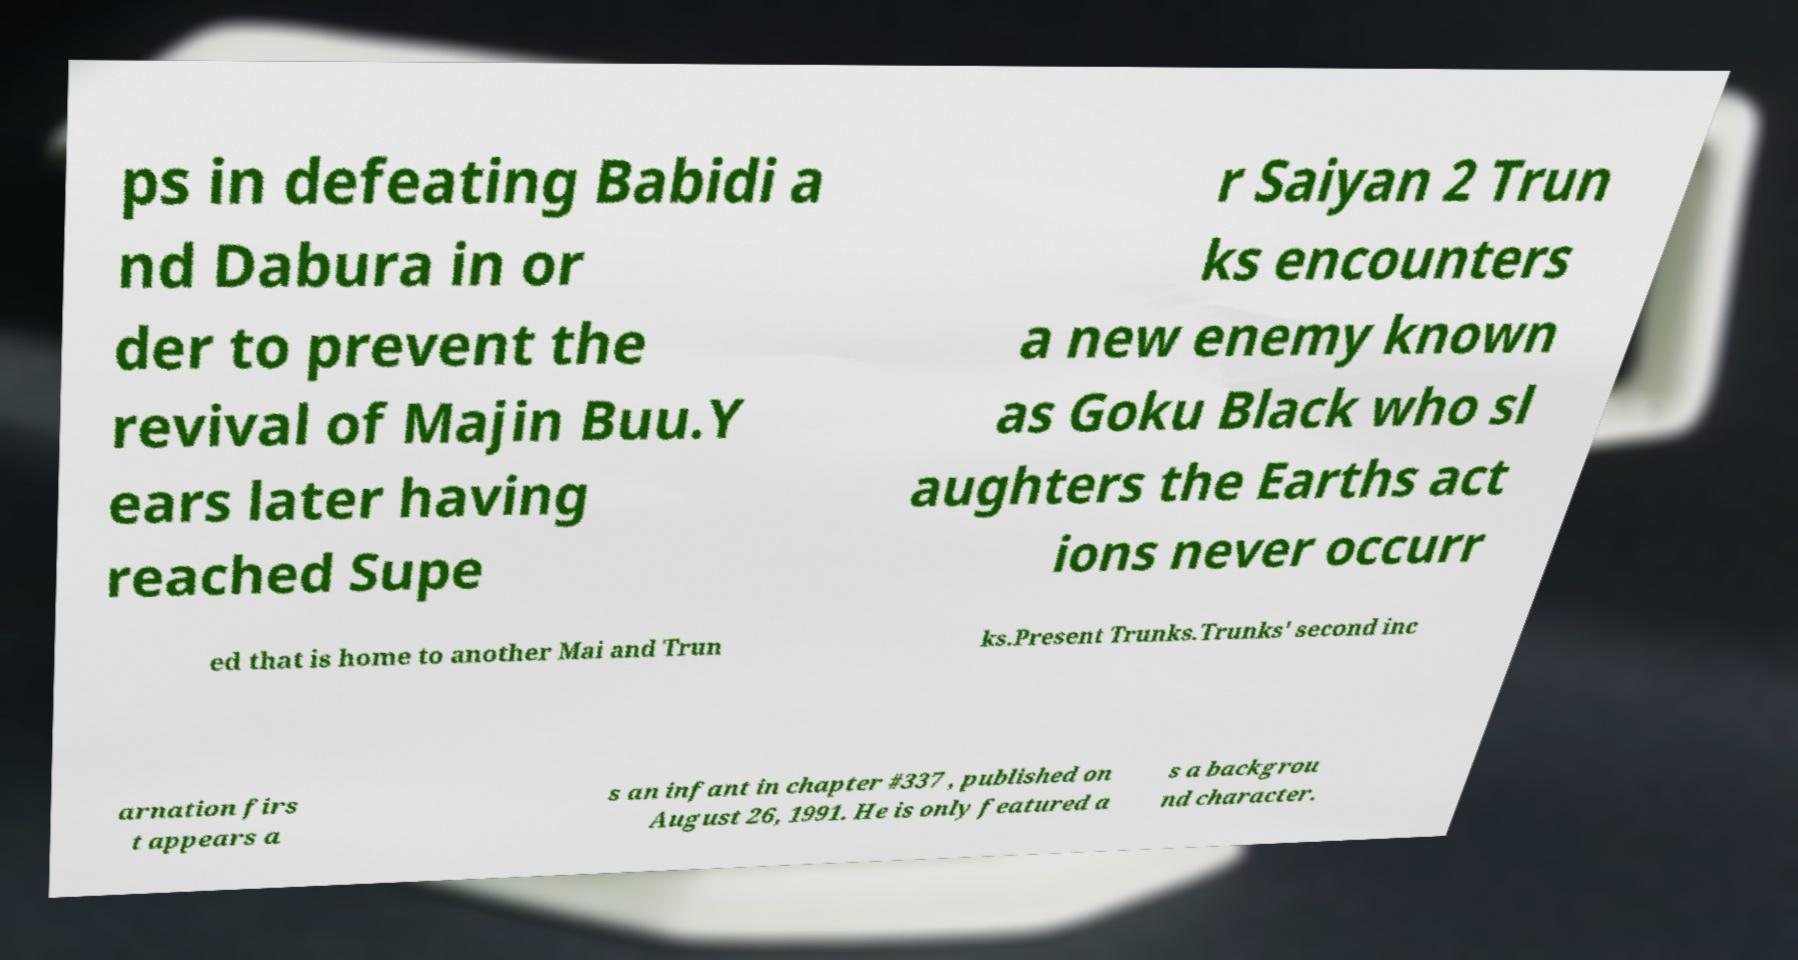Can you accurately transcribe the text from the provided image for me? ps in defeating Babidi a nd Dabura in or der to prevent the revival of Majin Buu.Y ears later having reached Supe r Saiyan 2 Trun ks encounters a new enemy known as Goku Black who sl aughters the Earths act ions never occurr ed that is home to another Mai and Trun ks.Present Trunks.Trunks' second inc arnation firs t appears a s an infant in chapter #337 , published on August 26, 1991. He is only featured a s a backgrou nd character. 